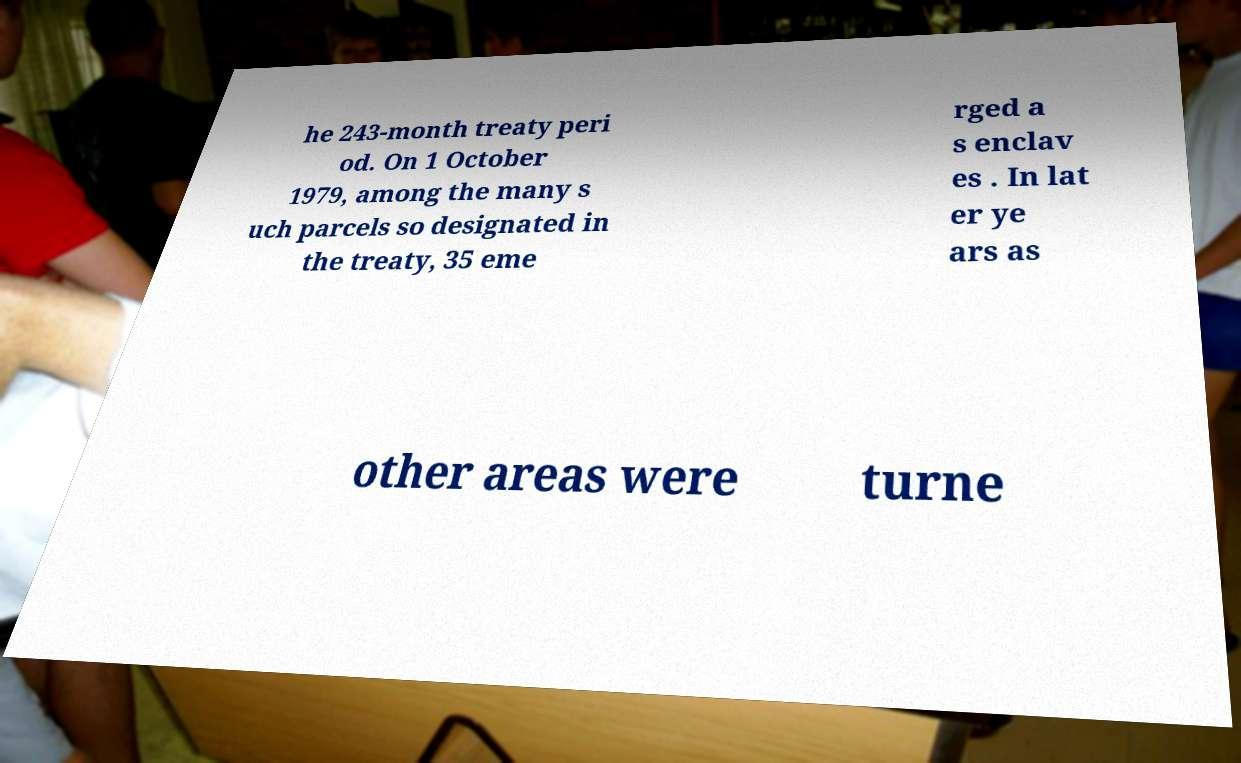I need the written content from this picture converted into text. Can you do that? he 243-month treaty peri od. On 1 October 1979, among the many s uch parcels so designated in the treaty, 35 eme rged a s enclav es . In lat er ye ars as other areas were turne 